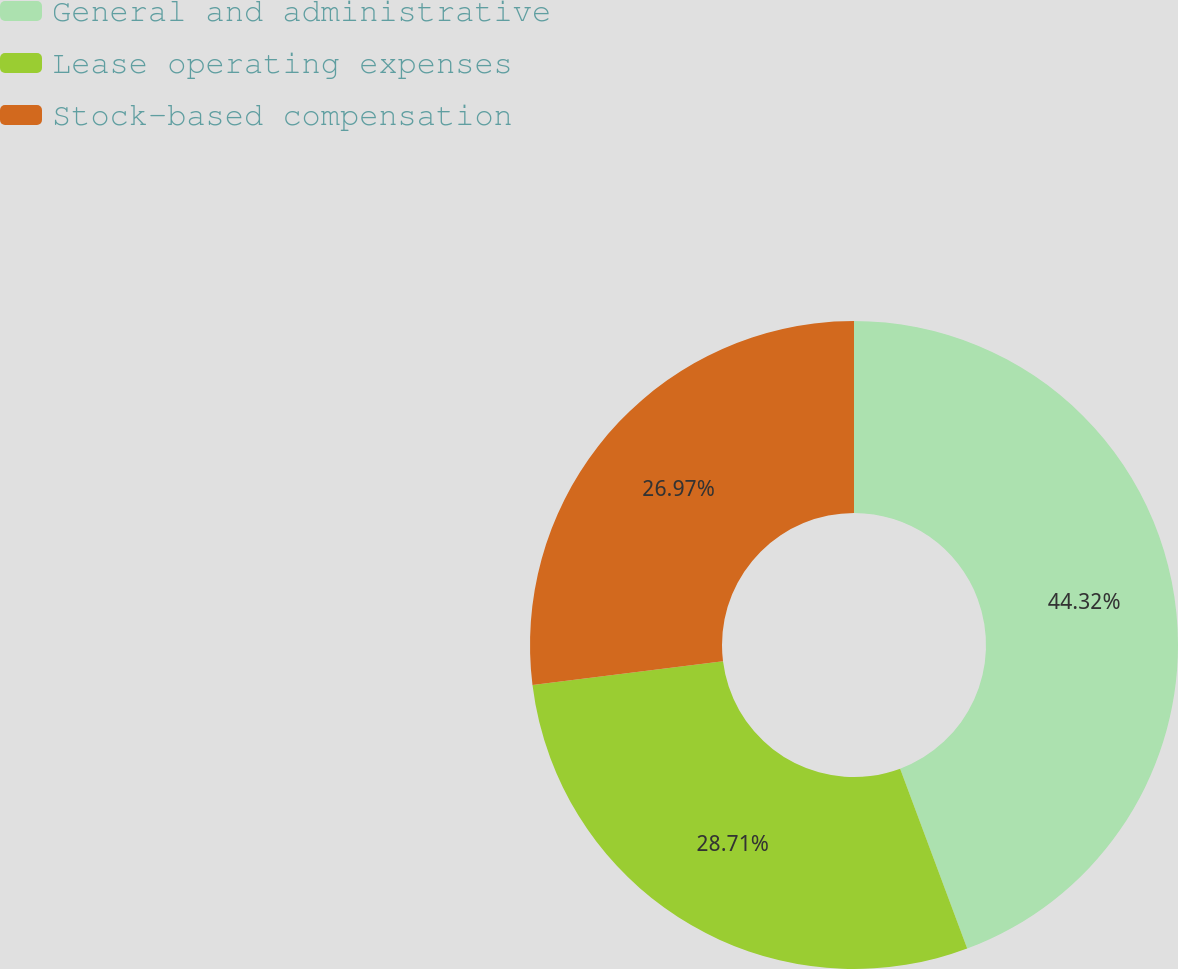Convert chart. <chart><loc_0><loc_0><loc_500><loc_500><pie_chart><fcel>General and administrative<fcel>Lease operating expenses<fcel>Stock-based compensation<nl><fcel>44.32%<fcel>28.71%<fcel>26.97%<nl></chart> 